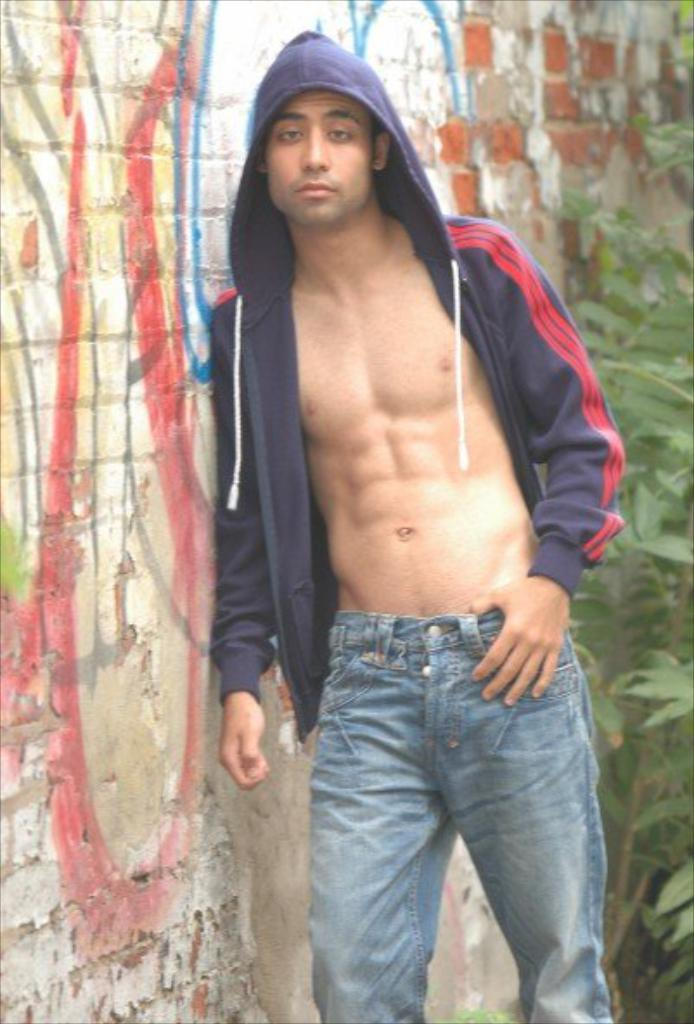Who is the main subject in the image? There is a man standing in the center of the image. What is the man wearing in the image? The man is wearing a hoodie. What can be seen on the left side of the image? There is a wall on the left side of the image. What type of vegetation is on the right side of the image? There is a plant on the right side of the image. What sign is the man holding in the image? A: There is no sign present in the image; the man is not holding anything. What type of club is the man using to interact with the plant in the image? There is no club present in the image, and the man is not interacting with the plant. 